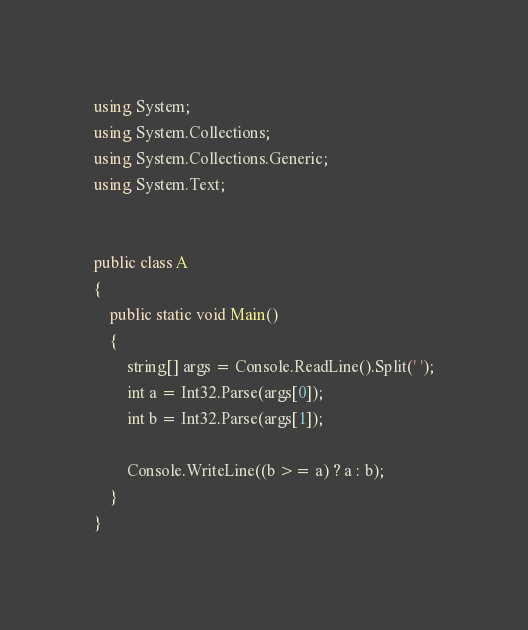<code> <loc_0><loc_0><loc_500><loc_500><_C#_>using System;
using System.Collections;
using System.Collections.Generic;
using System.Text;


public class A
{
	public static void Main()
	{
		string[] args = Console.ReadLine().Split(' ');
		int a = Int32.Parse(args[0]);
		int b = Int32.Parse(args[1]);

		Console.WriteLine((b >= a) ? a : b);
	}
}



</code> 